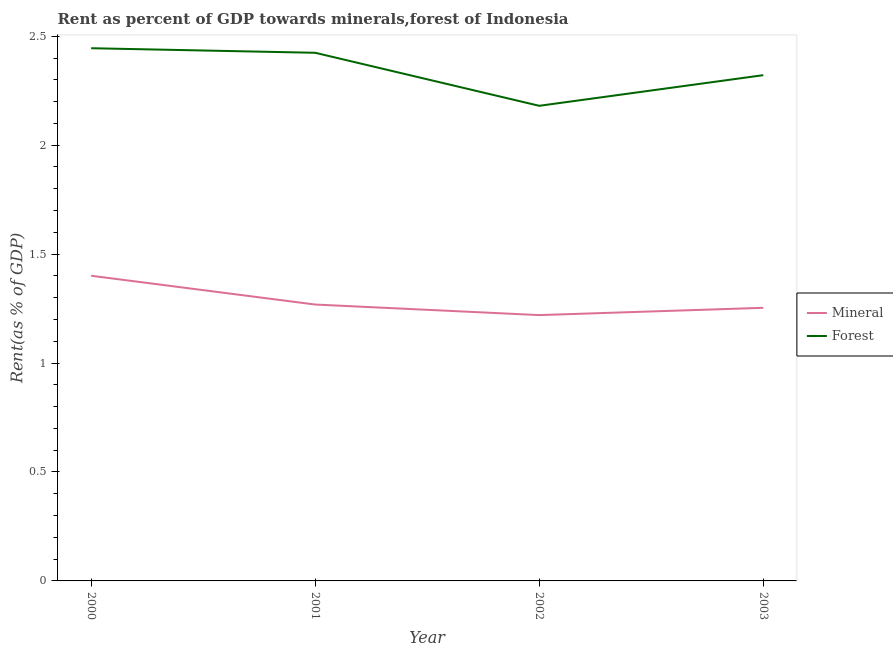How many different coloured lines are there?
Offer a terse response. 2. Is the number of lines equal to the number of legend labels?
Your answer should be compact. Yes. What is the mineral rent in 2000?
Provide a succinct answer. 1.4. Across all years, what is the maximum mineral rent?
Offer a terse response. 1.4. Across all years, what is the minimum forest rent?
Offer a terse response. 2.18. In which year was the mineral rent minimum?
Your answer should be very brief. 2002. What is the total forest rent in the graph?
Provide a short and direct response. 9.37. What is the difference between the forest rent in 2000 and that in 2003?
Ensure brevity in your answer.  0.12. What is the difference between the mineral rent in 2000 and the forest rent in 2001?
Offer a very short reply. -1.02. What is the average forest rent per year?
Your answer should be compact. 2.34. In the year 2001, what is the difference between the forest rent and mineral rent?
Offer a terse response. 1.16. What is the ratio of the forest rent in 2000 to that in 2002?
Ensure brevity in your answer.  1.12. Is the forest rent in 2000 less than that in 2003?
Provide a short and direct response. No. Is the difference between the forest rent in 2000 and 2001 greater than the difference between the mineral rent in 2000 and 2001?
Keep it short and to the point. No. What is the difference between the highest and the second highest forest rent?
Provide a succinct answer. 0.02. What is the difference between the highest and the lowest mineral rent?
Your response must be concise. 0.18. Does the forest rent monotonically increase over the years?
Ensure brevity in your answer.  No. Is the forest rent strictly greater than the mineral rent over the years?
Give a very brief answer. Yes. Does the graph contain any zero values?
Your answer should be very brief. No. Where does the legend appear in the graph?
Offer a very short reply. Center right. What is the title of the graph?
Give a very brief answer. Rent as percent of GDP towards minerals,forest of Indonesia. What is the label or title of the X-axis?
Your response must be concise. Year. What is the label or title of the Y-axis?
Your response must be concise. Rent(as % of GDP). What is the Rent(as % of GDP) of Mineral in 2000?
Your answer should be very brief. 1.4. What is the Rent(as % of GDP) of Forest in 2000?
Your response must be concise. 2.44. What is the Rent(as % of GDP) of Mineral in 2001?
Give a very brief answer. 1.27. What is the Rent(as % of GDP) in Forest in 2001?
Provide a succinct answer. 2.42. What is the Rent(as % of GDP) of Mineral in 2002?
Make the answer very short. 1.22. What is the Rent(as % of GDP) in Forest in 2002?
Provide a short and direct response. 2.18. What is the Rent(as % of GDP) in Mineral in 2003?
Your response must be concise. 1.25. What is the Rent(as % of GDP) of Forest in 2003?
Provide a succinct answer. 2.32. Across all years, what is the maximum Rent(as % of GDP) in Mineral?
Offer a terse response. 1.4. Across all years, what is the maximum Rent(as % of GDP) in Forest?
Give a very brief answer. 2.44. Across all years, what is the minimum Rent(as % of GDP) in Mineral?
Offer a very short reply. 1.22. Across all years, what is the minimum Rent(as % of GDP) of Forest?
Give a very brief answer. 2.18. What is the total Rent(as % of GDP) of Mineral in the graph?
Ensure brevity in your answer.  5.14. What is the total Rent(as % of GDP) in Forest in the graph?
Give a very brief answer. 9.37. What is the difference between the Rent(as % of GDP) in Mineral in 2000 and that in 2001?
Give a very brief answer. 0.13. What is the difference between the Rent(as % of GDP) of Forest in 2000 and that in 2001?
Ensure brevity in your answer.  0.02. What is the difference between the Rent(as % of GDP) of Mineral in 2000 and that in 2002?
Your answer should be very brief. 0.18. What is the difference between the Rent(as % of GDP) of Forest in 2000 and that in 2002?
Provide a succinct answer. 0.26. What is the difference between the Rent(as % of GDP) in Mineral in 2000 and that in 2003?
Provide a short and direct response. 0.15. What is the difference between the Rent(as % of GDP) of Forest in 2000 and that in 2003?
Offer a very short reply. 0.12. What is the difference between the Rent(as % of GDP) in Mineral in 2001 and that in 2002?
Ensure brevity in your answer.  0.05. What is the difference between the Rent(as % of GDP) in Forest in 2001 and that in 2002?
Ensure brevity in your answer.  0.24. What is the difference between the Rent(as % of GDP) of Mineral in 2001 and that in 2003?
Offer a terse response. 0.01. What is the difference between the Rent(as % of GDP) of Forest in 2001 and that in 2003?
Make the answer very short. 0.1. What is the difference between the Rent(as % of GDP) in Mineral in 2002 and that in 2003?
Your response must be concise. -0.03. What is the difference between the Rent(as % of GDP) of Forest in 2002 and that in 2003?
Make the answer very short. -0.14. What is the difference between the Rent(as % of GDP) in Mineral in 2000 and the Rent(as % of GDP) in Forest in 2001?
Offer a very short reply. -1.02. What is the difference between the Rent(as % of GDP) of Mineral in 2000 and the Rent(as % of GDP) of Forest in 2002?
Your answer should be compact. -0.78. What is the difference between the Rent(as % of GDP) of Mineral in 2000 and the Rent(as % of GDP) of Forest in 2003?
Offer a very short reply. -0.92. What is the difference between the Rent(as % of GDP) of Mineral in 2001 and the Rent(as % of GDP) of Forest in 2002?
Your answer should be very brief. -0.91. What is the difference between the Rent(as % of GDP) in Mineral in 2001 and the Rent(as % of GDP) in Forest in 2003?
Offer a very short reply. -1.05. What is the difference between the Rent(as % of GDP) in Mineral in 2002 and the Rent(as % of GDP) in Forest in 2003?
Your answer should be very brief. -1.1. What is the average Rent(as % of GDP) in Forest per year?
Ensure brevity in your answer.  2.34. In the year 2000, what is the difference between the Rent(as % of GDP) in Mineral and Rent(as % of GDP) in Forest?
Your response must be concise. -1.04. In the year 2001, what is the difference between the Rent(as % of GDP) in Mineral and Rent(as % of GDP) in Forest?
Offer a terse response. -1.16. In the year 2002, what is the difference between the Rent(as % of GDP) in Mineral and Rent(as % of GDP) in Forest?
Offer a very short reply. -0.96. In the year 2003, what is the difference between the Rent(as % of GDP) of Mineral and Rent(as % of GDP) of Forest?
Offer a very short reply. -1.07. What is the ratio of the Rent(as % of GDP) in Mineral in 2000 to that in 2001?
Ensure brevity in your answer.  1.1. What is the ratio of the Rent(as % of GDP) in Forest in 2000 to that in 2001?
Offer a very short reply. 1.01. What is the ratio of the Rent(as % of GDP) in Mineral in 2000 to that in 2002?
Your answer should be very brief. 1.15. What is the ratio of the Rent(as % of GDP) of Forest in 2000 to that in 2002?
Ensure brevity in your answer.  1.12. What is the ratio of the Rent(as % of GDP) in Mineral in 2000 to that in 2003?
Give a very brief answer. 1.12. What is the ratio of the Rent(as % of GDP) of Forest in 2000 to that in 2003?
Provide a short and direct response. 1.05. What is the ratio of the Rent(as % of GDP) in Mineral in 2001 to that in 2002?
Make the answer very short. 1.04. What is the ratio of the Rent(as % of GDP) in Forest in 2001 to that in 2002?
Provide a succinct answer. 1.11. What is the ratio of the Rent(as % of GDP) of Forest in 2001 to that in 2003?
Provide a succinct answer. 1.04. What is the ratio of the Rent(as % of GDP) of Mineral in 2002 to that in 2003?
Give a very brief answer. 0.97. What is the ratio of the Rent(as % of GDP) in Forest in 2002 to that in 2003?
Provide a short and direct response. 0.94. What is the difference between the highest and the second highest Rent(as % of GDP) of Mineral?
Provide a succinct answer. 0.13. What is the difference between the highest and the second highest Rent(as % of GDP) of Forest?
Give a very brief answer. 0.02. What is the difference between the highest and the lowest Rent(as % of GDP) of Mineral?
Offer a very short reply. 0.18. What is the difference between the highest and the lowest Rent(as % of GDP) of Forest?
Keep it short and to the point. 0.26. 